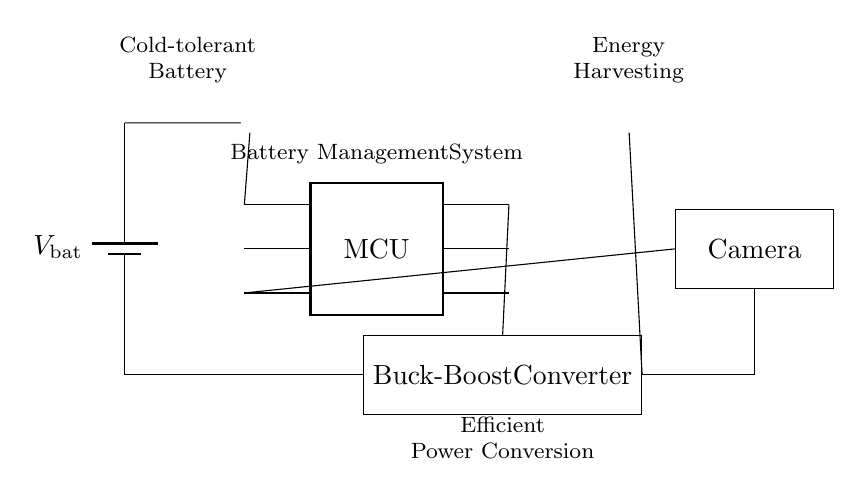what type of sensor is used in this circuit? The circuit diagram includes a thermistor labeled as a temperature sensor, indicating that it measures temperature.
Answer: Temperature sensor what components are responsible for energy harvesting? The solar panel is depicted in the circuit as a photovoltaic source, which is designed to capture solar energy and convert it into electrical energy.
Answer: Solar panel where does the battery connect in the circuit? The battery is connected at the bottom, linking directly to the buck-boost converter. The positive terminal connects to the converter's western side.
Answer: To the buck-boost converter which component controls the entire system? The microcontroller, labeled as MCU, manages the inputs from the temperature sensor and directs power to the camera as well as communicates with the converter.
Answer: Microcontroller what is the function of the buck-boost converter in this circuit? The buck-boost converter adjusts the battery voltage level up or down as needed for compatibility with the camera and other circuit components, ensuring efficient power conversion.
Answer: Efficient power conversion how does the temperature sensor influence the system's operation? The temperature sensor feeds temperature data to the microcontroller, which can adjust the system performance based on the detected temperature, particularly to safeguard against low temperatures affecting battery performance.
Answer: Adjusts system performance what load does the circuit supply power to? The camera is shown as the load in the circuit, which receives power from both the buck-boost converter and the microcontroller.
Answer: Camera 